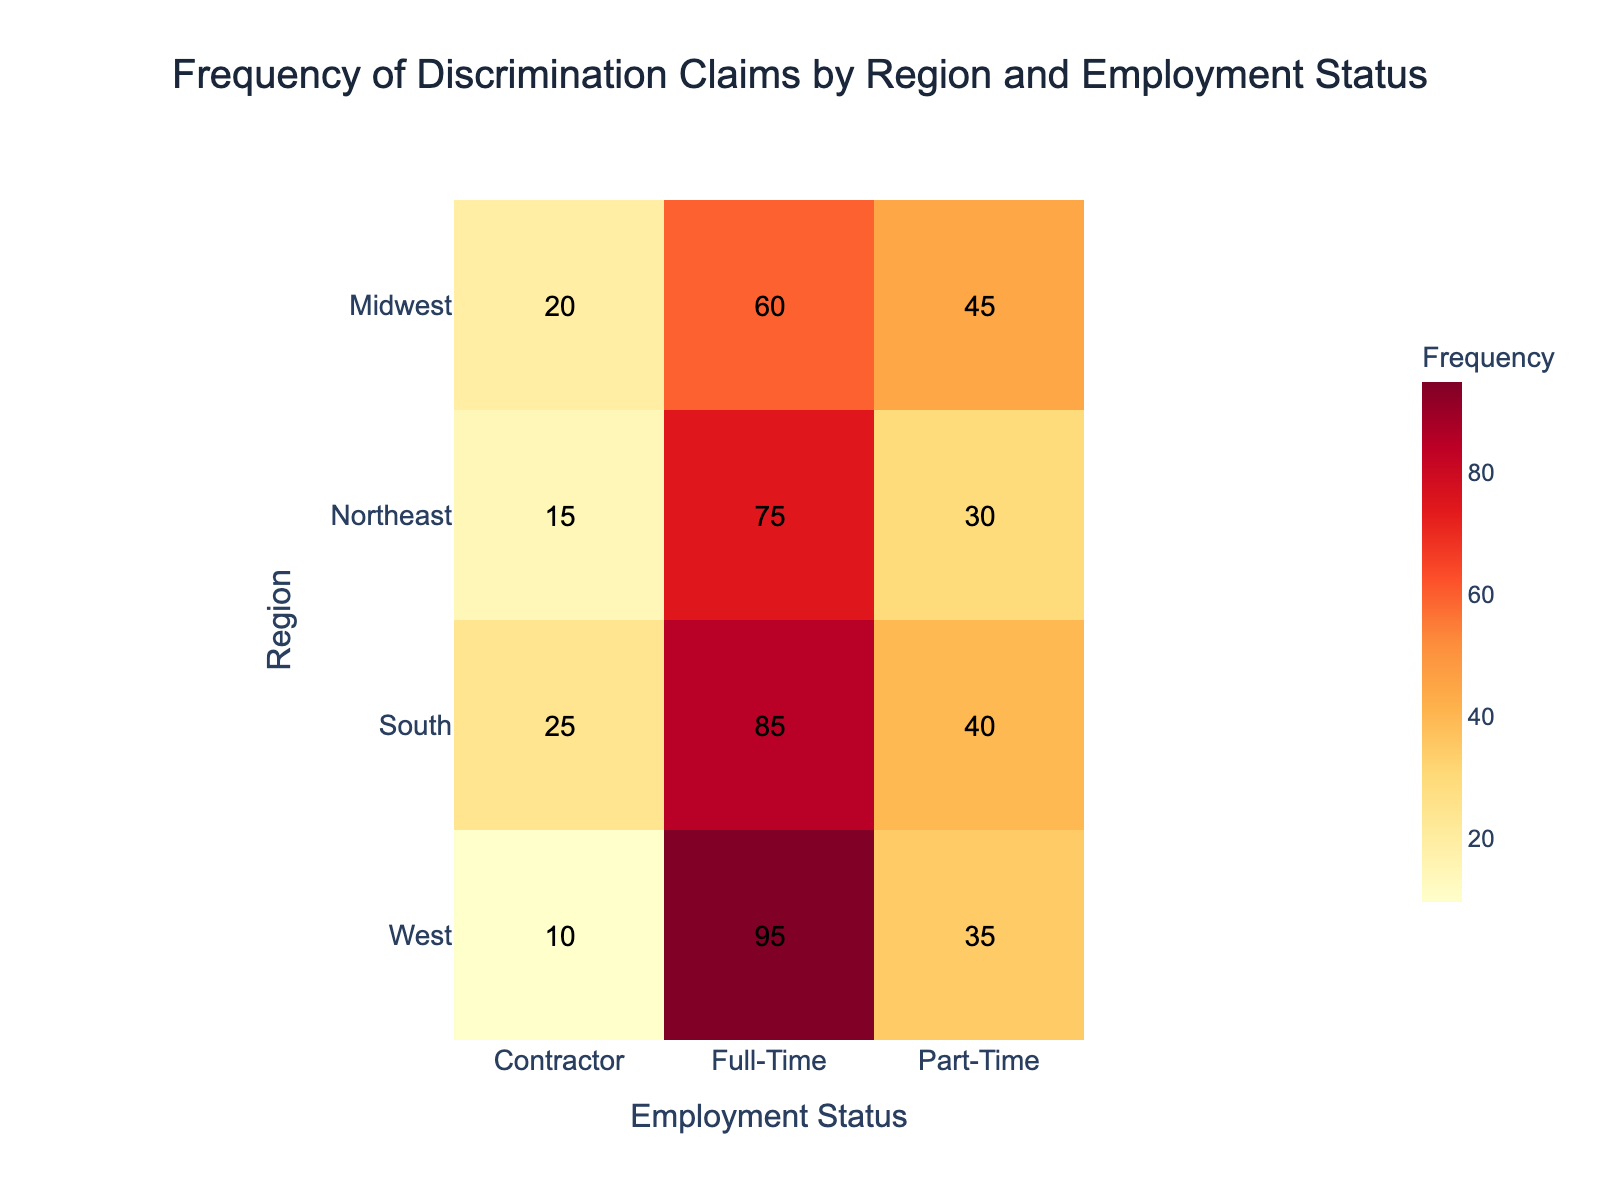What is the title of the heatmap? The title of the heatmap is located at the top center of the figure and provides a brief description of the data being presented.
Answer: Frequency of Discrimination Claims by Region and Employment Status Which region has the highest frequency of claims for full-time employees? To determine this, scan through the values in the full-time column and identify the highest number.
Answer: West What is the total frequency of claims in the Northeast region? Sum the frequency of claims for full-time, part-time, and contractor employment statuses in the Northeast. Calculation: 75 + 30 + 15 = 120.
Answer: 120 How does the frequency of claims for part-time employees in the Midwest compare to the South? Compare the numerical values of the part-time claims between the Midwest and the South; Midwest has 45 and South has 40.
Answer: Midwest has higher claims What is the difference in the frequency of claims between full-time and part-time employees in the West? Subtract the value of part-time claims from the value of full-time claims in the West. Calculation: 95 - 35 = 60.
Answer: 60 Which region has the lowest frequency of claims overall? Sum the frequency of claims across all employment statuses for each region, and then compare the sums to find the region with the lowest total: Northeast (120), Midwest (125), South (150), West (140).
Answer: Northeast What are the employment statuses considered in this heatmap? Look at the x-axis labels which indicate the different types of employment statuses analyzed.
Answer: Full-Time, Part-Time, Contractor Are there any regions where contractors have the highest frequency of claims compared to other employment statuses in that region? Compare the frequency of claims of contractors with full-time and part-time employees within each region.
Answer: No Which employment status in the South has closer frequency claims to those in the Northeast part-time? Compare the frequency claims of each employment status in the South with 30 (Northeast Part-Time). Calculation: Full-Time (85), Part-Time (40), Contractor (25). Contractor and Part-Time are closer to 30.
Answer: Contractor How do the frequencies of part-time claims vary across different regions? Review the frequency values in the part-time column for each region. Values: Northeast (30), Midwest (45), South (40), West (35).
Answer: Northeast: 30, Midwest: 45, South: 40, West: 35 